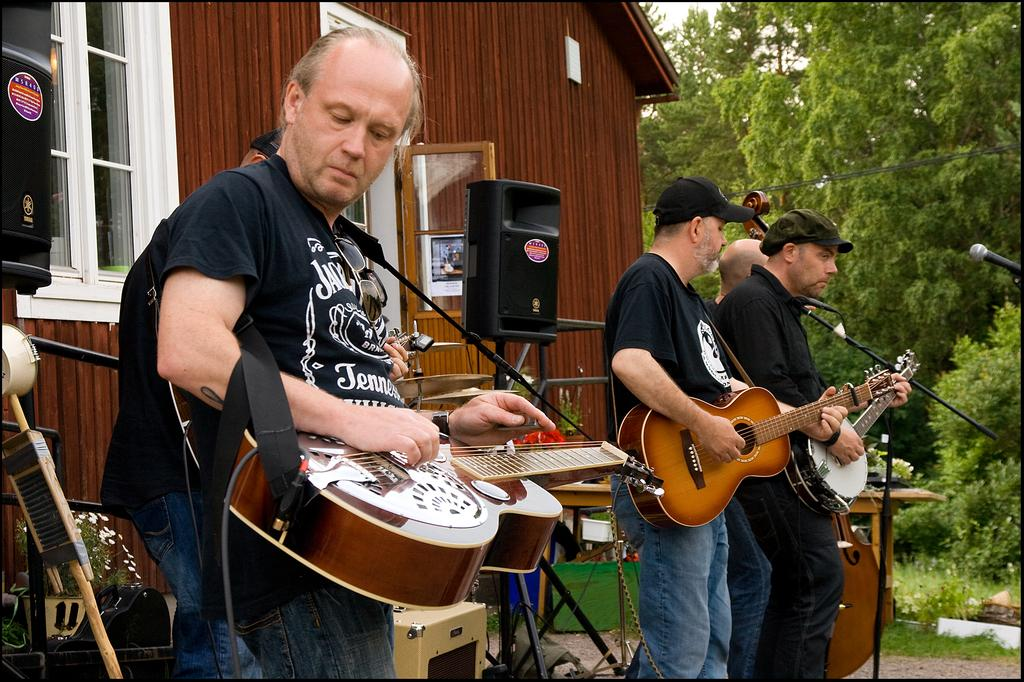What are the persons in the image doing? The persons in the image are playing musical instruments. What object resembles a speaker in the image? There is an object that looks like a speaker in the image. What can be seen in the background of the image? There is a house and trees in the background. How many beggars are present in the image? There are no beggars present in the image. What is the level of shame experienced by the persons playing musical instruments in the image? There is no indication of shame in the image, as the persons are simply playing musical instruments. 